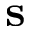<formula> <loc_0><loc_0><loc_500><loc_500>s</formula> 